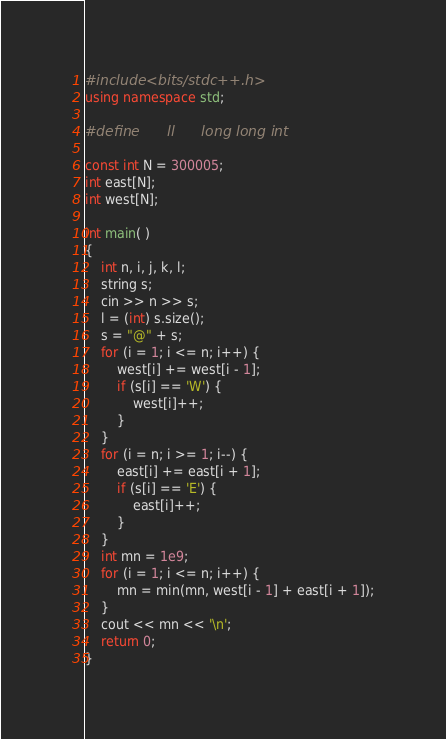<code> <loc_0><loc_0><loc_500><loc_500><_C++_>#include <bits/stdc++.h>
using namespace std;

#define      ll      long long int

const int N = 300005;
int east[N];
int west[N];

int main( )
{
    int n, i, j, k, l;
    string s;
    cin >> n >> s;
    l = (int) s.size();
    s = "@" + s;
    for (i = 1; i <= n; i++) {
        west[i] += west[i - 1];
        if (s[i] == 'W') {
            west[i]++;
        }
    }
    for (i = n; i >= 1; i--) {
        east[i] += east[i + 1];
        if (s[i] == 'E') {
            east[i]++;
        }
    }
    int mn = 1e9;
    for (i = 1; i <= n; i++) {
        mn = min(mn, west[i - 1] + east[i + 1]);
    }
    cout << mn << '\n';
    return 0;
}

</code> 